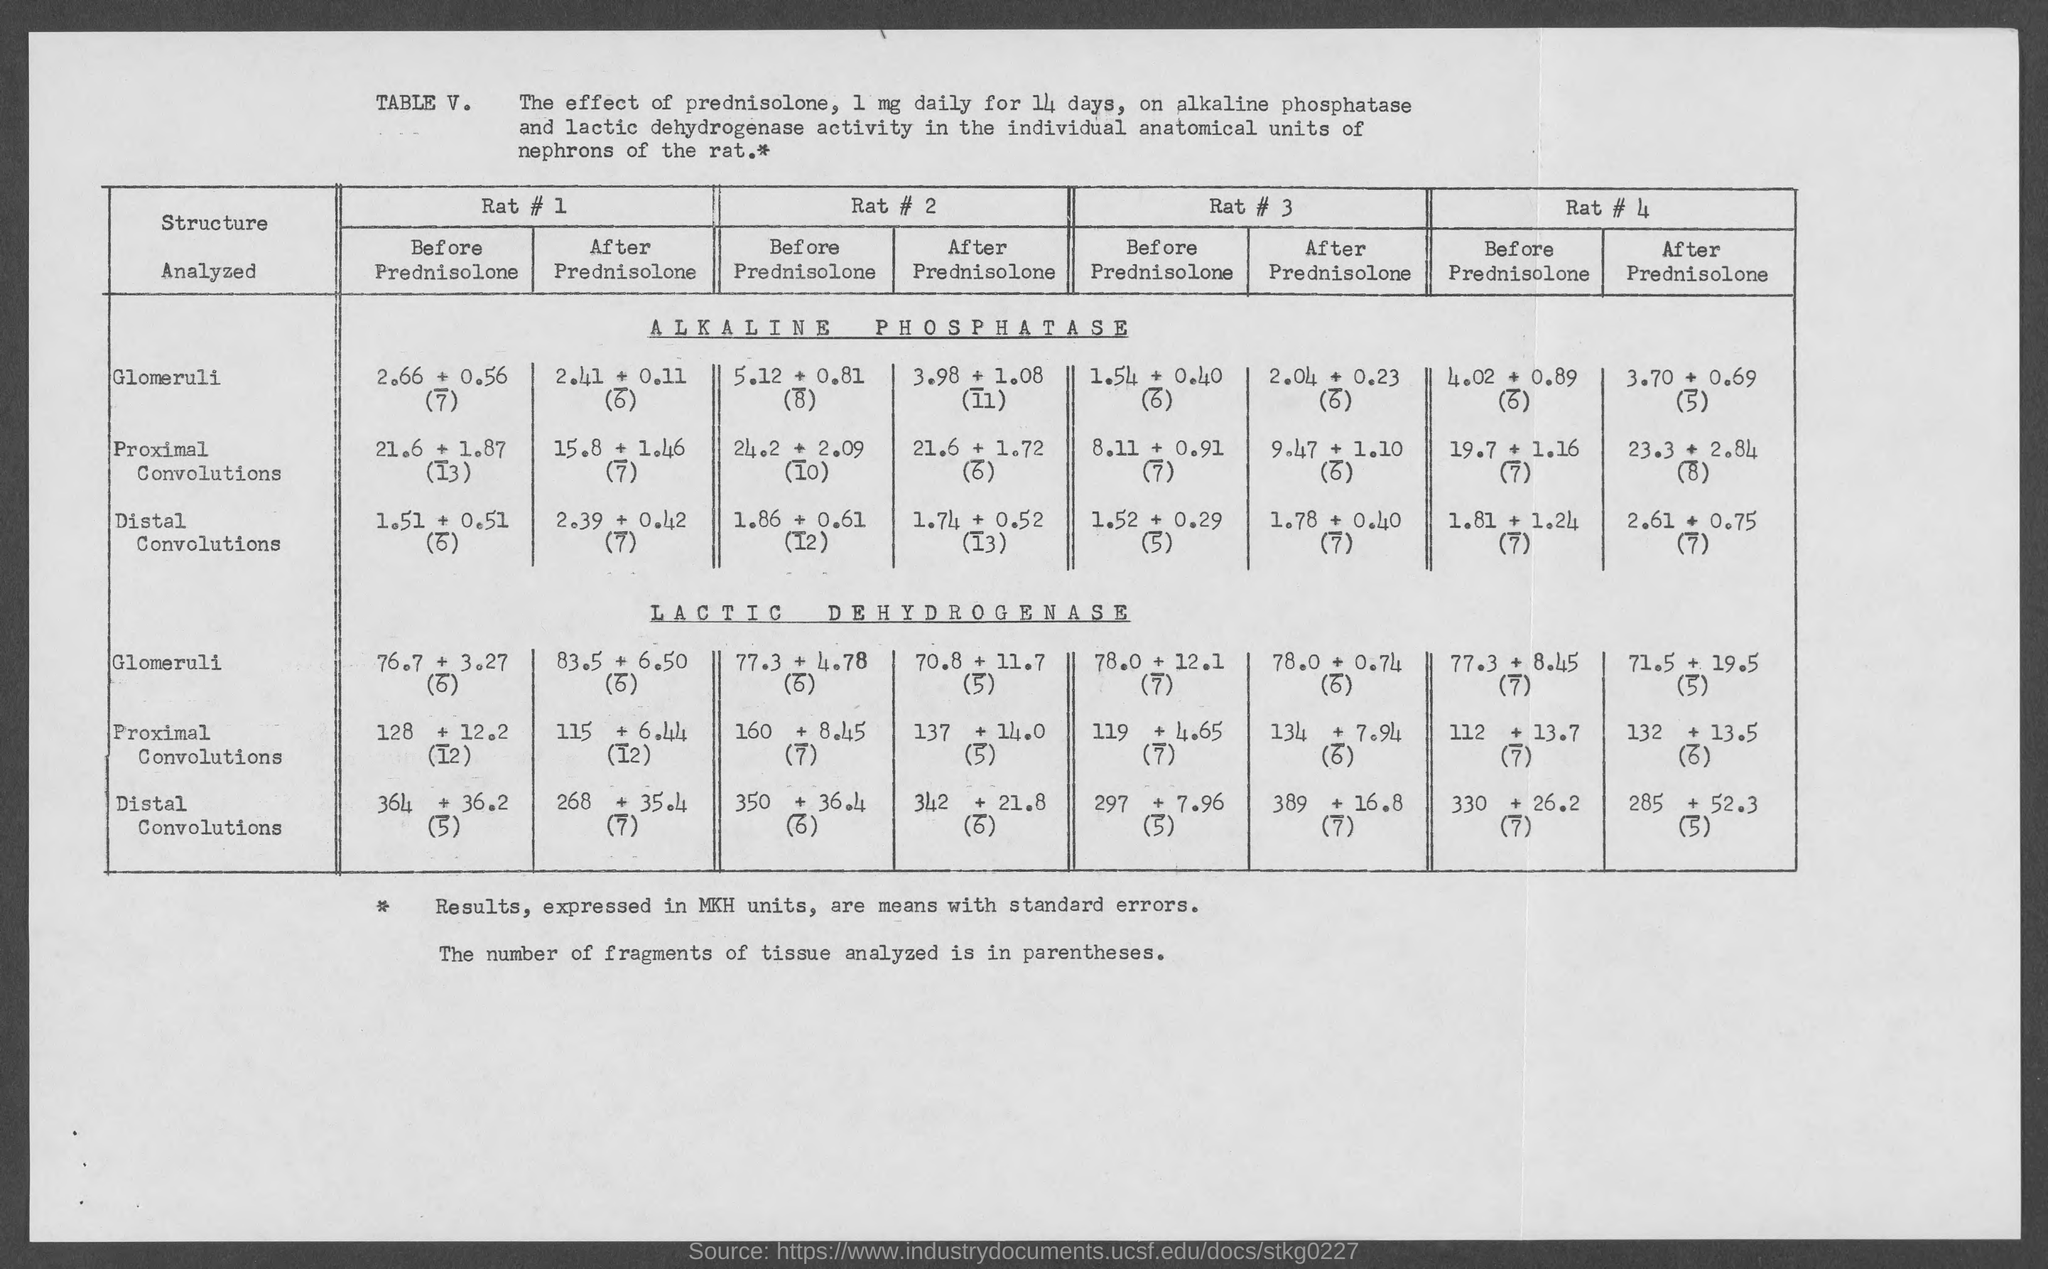Give some essential details in this illustration. What is the table number? The table is located at Table V.. 